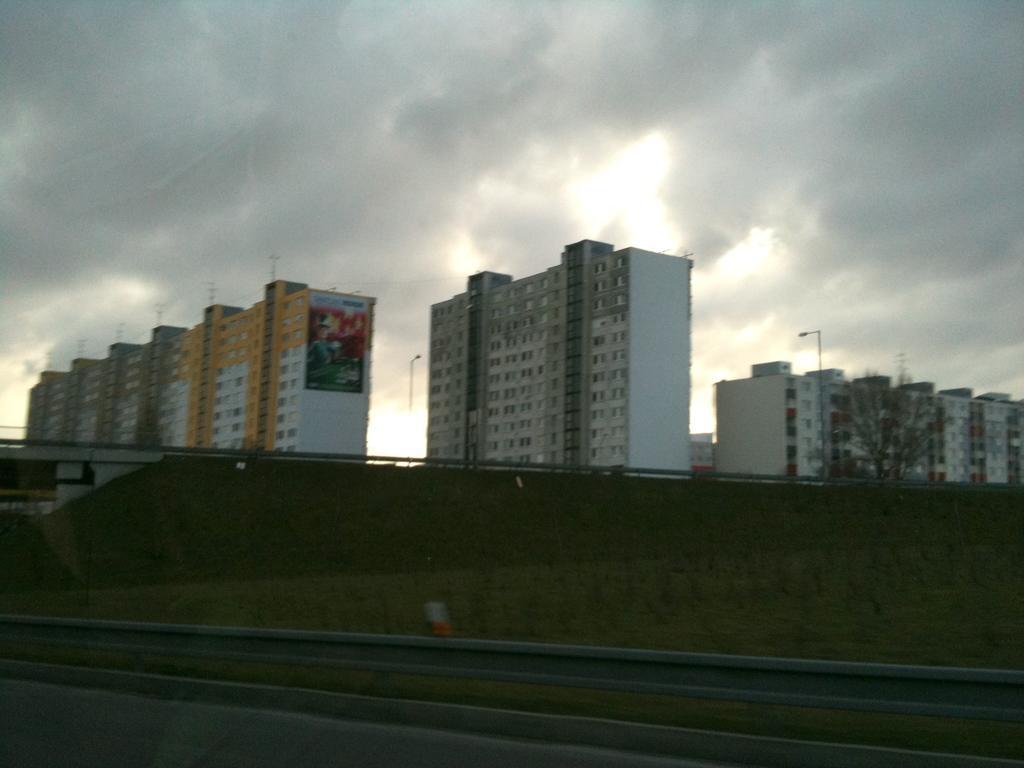Describe this image in one or two sentences. This picture is clicked outside. In the foreground we can see the ground. In the center we can see the metal rods, street lights, poles, tree and the buildings. In the background there is a sky which is full of clouds. 